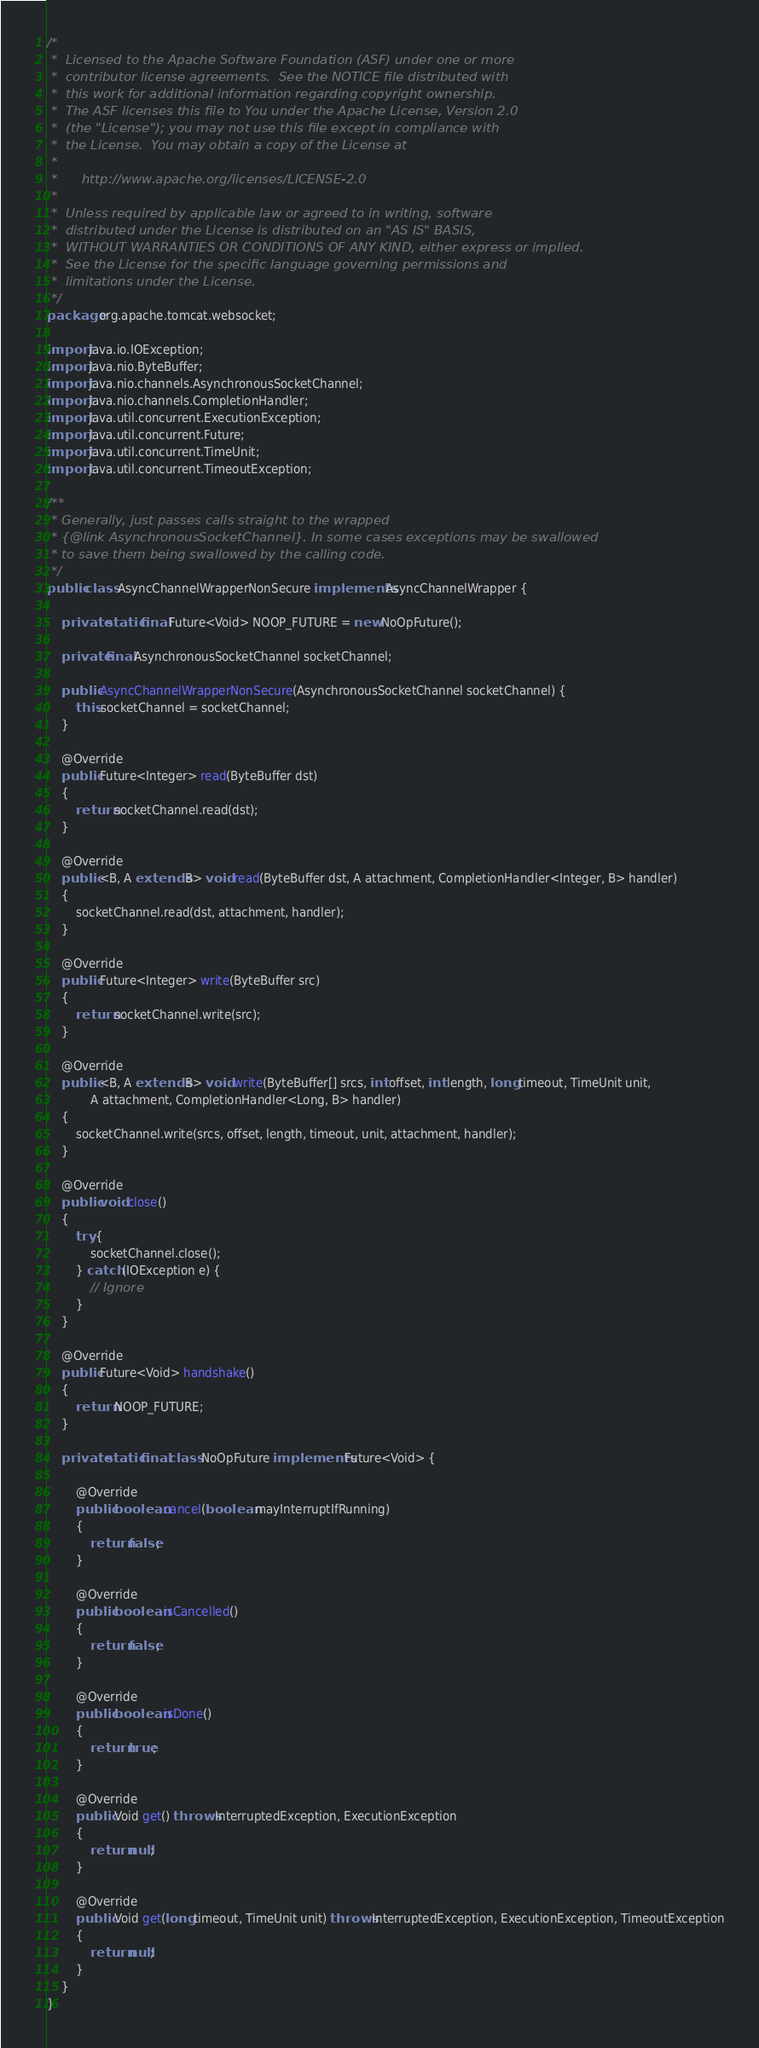Convert code to text. <code><loc_0><loc_0><loc_500><loc_500><_Java_>/*
 *  Licensed to the Apache Software Foundation (ASF) under one or more
 *  contributor license agreements.  See the NOTICE file distributed with
 *  this work for additional information regarding copyright ownership.
 *  The ASF licenses this file to You under the Apache License, Version 2.0
 *  (the "License"); you may not use this file except in compliance with
 *  the License.  You may obtain a copy of the License at
 *
 *      http://www.apache.org/licenses/LICENSE-2.0
 *
 *  Unless required by applicable law or agreed to in writing, software
 *  distributed under the License is distributed on an "AS IS" BASIS,
 *  WITHOUT WARRANTIES OR CONDITIONS OF ANY KIND, either express or implied.
 *  See the License for the specific language governing permissions and
 *  limitations under the License.
 */
package org.apache.tomcat.websocket;

import java.io.IOException;
import java.nio.ByteBuffer;
import java.nio.channels.AsynchronousSocketChannel;
import java.nio.channels.CompletionHandler;
import java.util.concurrent.ExecutionException;
import java.util.concurrent.Future;
import java.util.concurrent.TimeUnit;
import java.util.concurrent.TimeoutException;

/**
 * Generally, just passes calls straight to the wrapped
 * {@link AsynchronousSocketChannel}. In some cases exceptions may be swallowed
 * to save them being swallowed by the calling code.
 */
public class AsyncChannelWrapperNonSecure implements AsyncChannelWrapper {

	private static final Future<Void> NOOP_FUTURE = new NoOpFuture();

	private final AsynchronousSocketChannel socketChannel;

	public AsyncChannelWrapperNonSecure(AsynchronousSocketChannel socketChannel) {
		this.socketChannel = socketChannel;
	}

	@Override
	public Future<Integer> read(ByteBuffer dst)
	{
		return socketChannel.read(dst);
	}

	@Override
	public <B, A extends B> void read(ByteBuffer dst, A attachment, CompletionHandler<Integer, B> handler)
	{
		socketChannel.read(dst, attachment, handler);
	}

	@Override
	public Future<Integer> write(ByteBuffer src)
	{
		return socketChannel.write(src);
	}

	@Override
	public <B, A extends B> void write(ByteBuffer[] srcs, int offset, int length, long timeout, TimeUnit unit,
			A attachment, CompletionHandler<Long, B> handler)
	{
		socketChannel.write(srcs, offset, length, timeout, unit, attachment, handler);
	}

	@Override
	public void close()
	{
		try {
			socketChannel.close();
		} catch (IOException e) {
			// Ignore
		}
	}

	@Override
	public Future<Void> handshake()
	{
		return NOOP_FUTURE;
	}

	private static final class NoOpFuture implements Future<Void> {

		@Override
		public boolean cancel(boolean mayInterruptIfRunning)
		{
			return false;
		}

		@Override
		public boolean isCancelled()
		{
			return false;
		}

		@Override
		public boolean isDone()
		{
			return true;
		}

		@Override
		public Void get() throws InterruptedException, ExecutionException
		{
			return null;
		}

		@Override
		public Void get(long timeout, TimeUnit unit) throws InterruptedException, ExecutionException, TimeoutException
		{
			return null;
		}
	}
}
</code> 